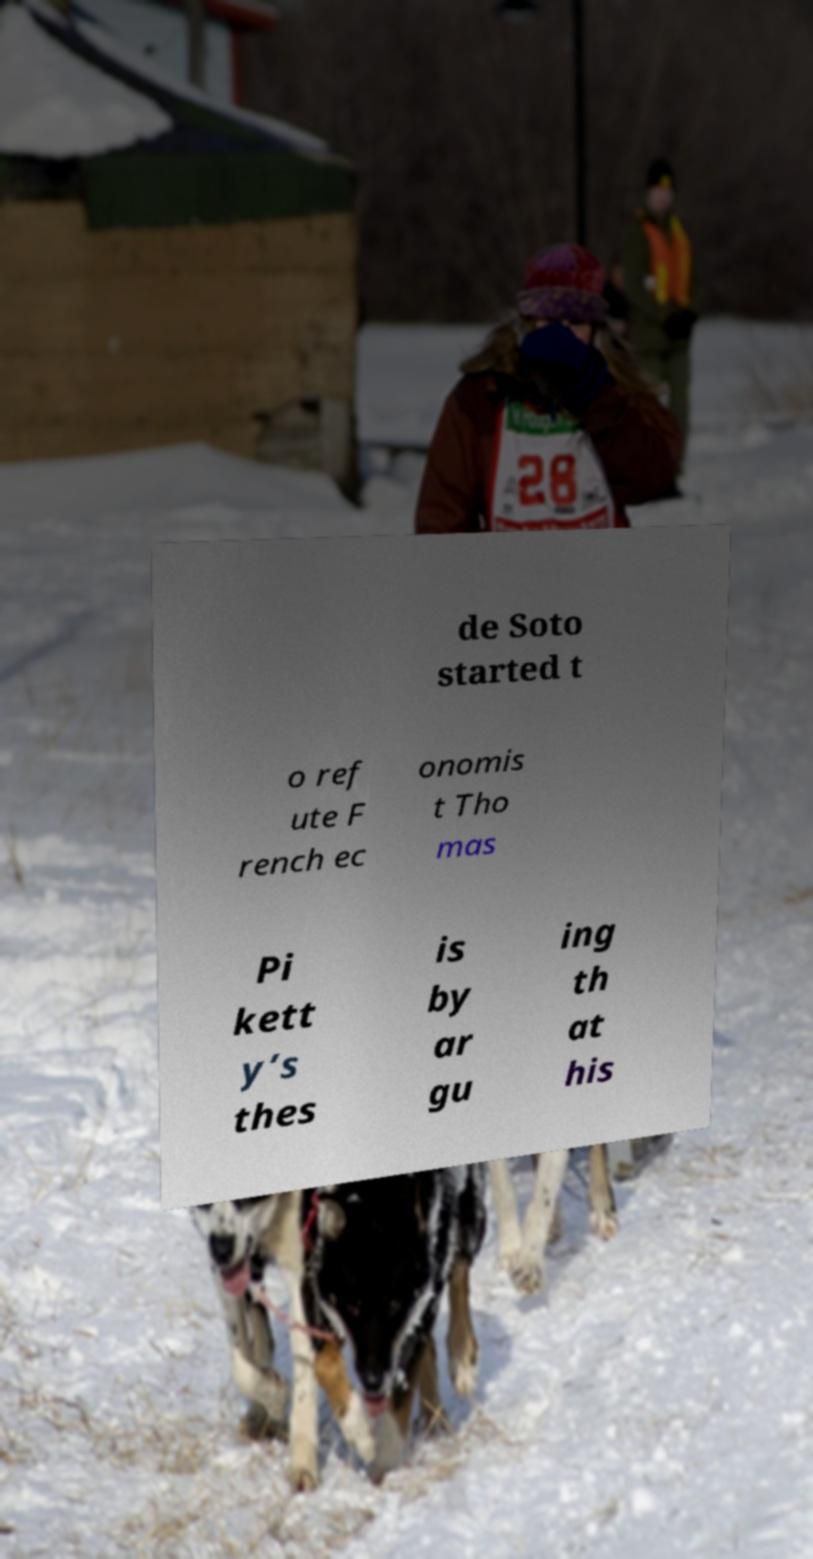Could you assist in decoding the text presented in this image and type it out clearly? de Soto started t o ref ute F rench ec onomis t Tho mas Pi kett y’s thes is by ar gu ing th at his 